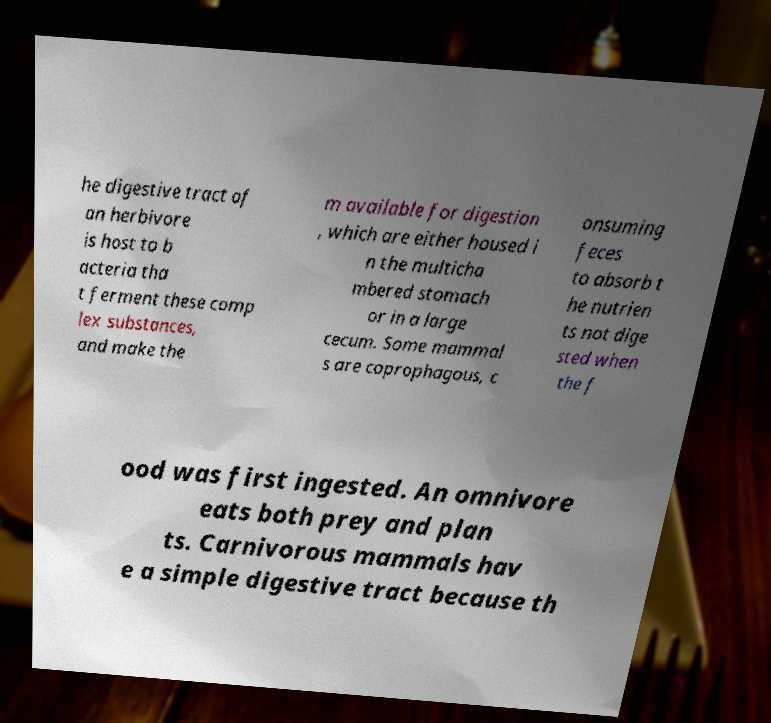Could you extract and type out the text from this image? he digestive tract of an herbivore is host to b acteria tha t ferment these comp lex substances, and make the m available for digestion , which are either housed i n the multicha mbered stomach or in a large cecum. Some mammal s are coprophagous, c onsuming feces to absorb t he nutrien ts not dige sted when the f ood was first ingested. An omnivore eats both prey and plan ts. Carnivorous mammals hav e a simple digestive tract because th 